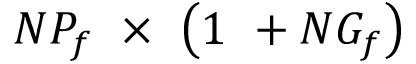Convert formula to latex. <formula><loc_0><loc_0><loc_500><loc_500>N P _ { f } \ \times \ \left ( 1 \ + N G _ { f } \right )</formula> 